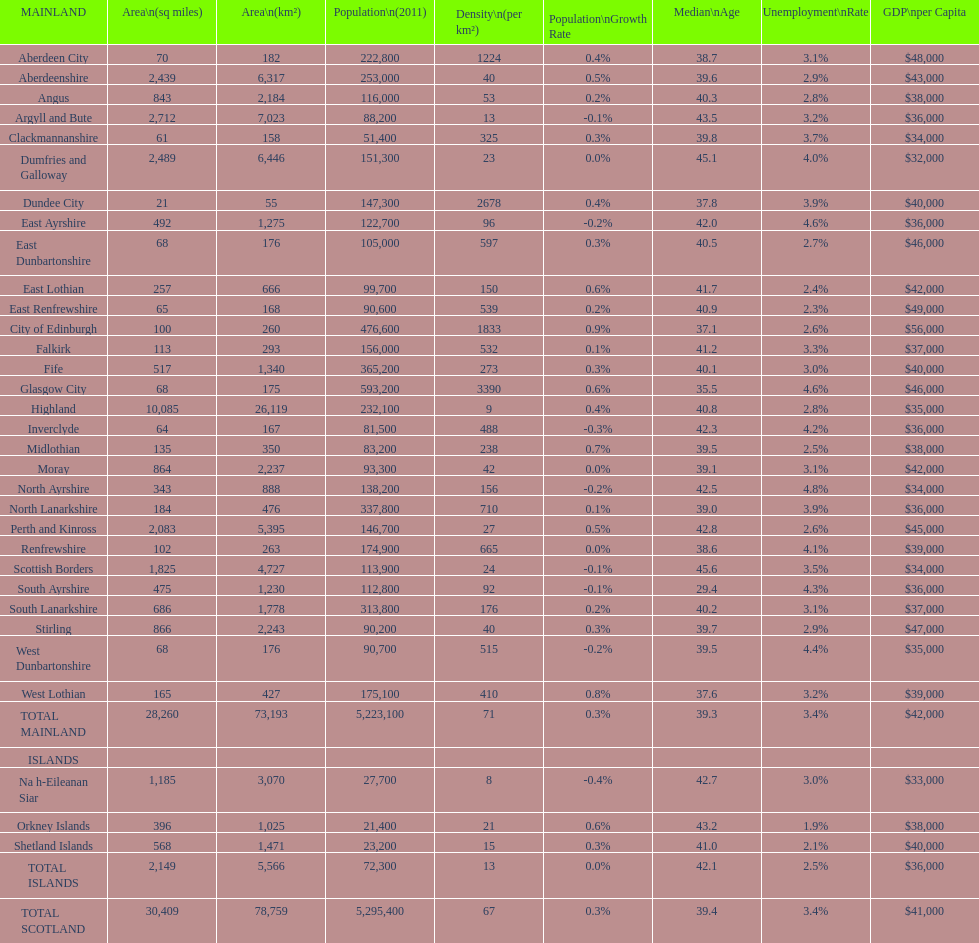If you were to arrange the locations from the smallest to largest area, which one would be first on the list? Dundee City. 